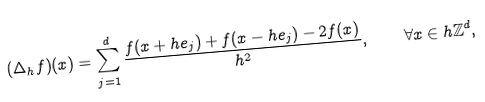Convert formula to latex. <formula><loc_0><loc_0><loc_500><loc_500>( \Delta _ { h } f ) ( x ) = \sum _ { j = 1 } ^ { d } \frac { f ( x + h e _ { j } ) + f ( x - h e _ { j } ) - 2 f ( x ) } { h ^ { 2 } } , \quad \forall x \in h \mathbb { Z } ^ { d } ,</formula> 